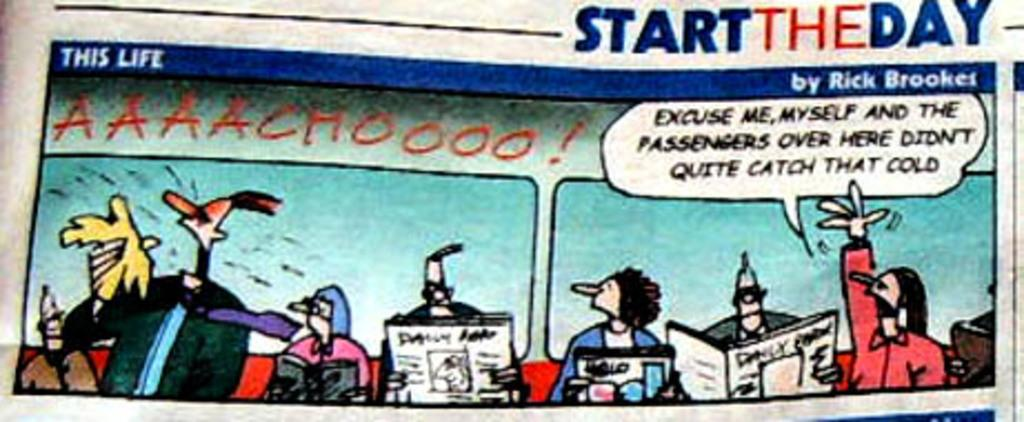<image>
Provide a brief description of the given image. A cartoon from STARTTHEDAY features a man reading a newspaper. 